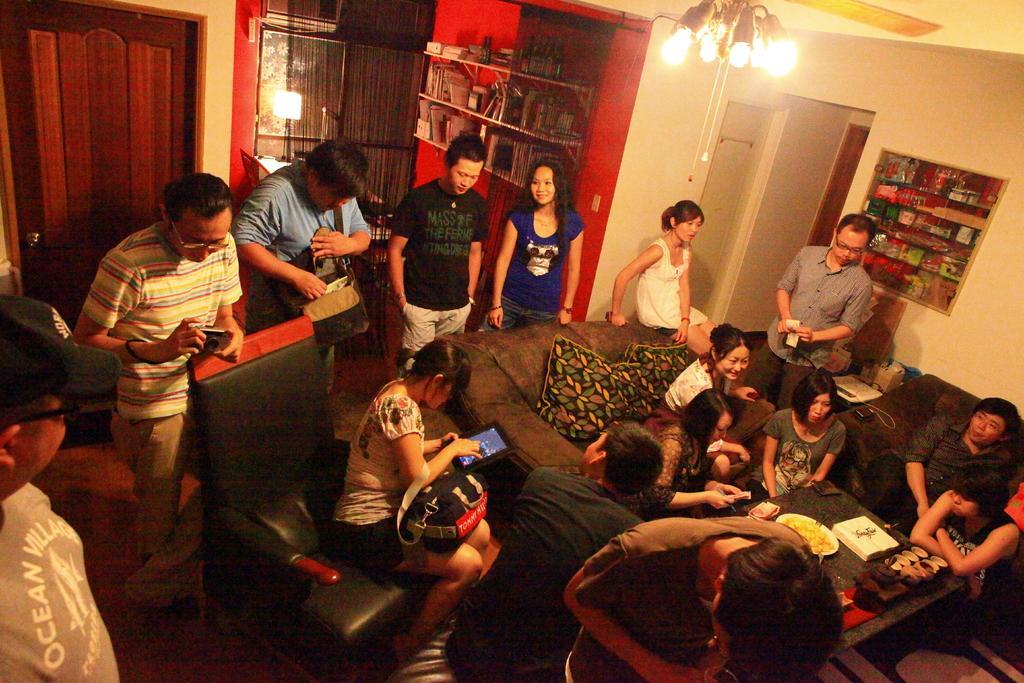Can you describe this image briefly? In this picture I can observe few people in the room. Some of them are sitting on the sofa. In the background I can observe shelf. In the top of the picture I can observe lights. 